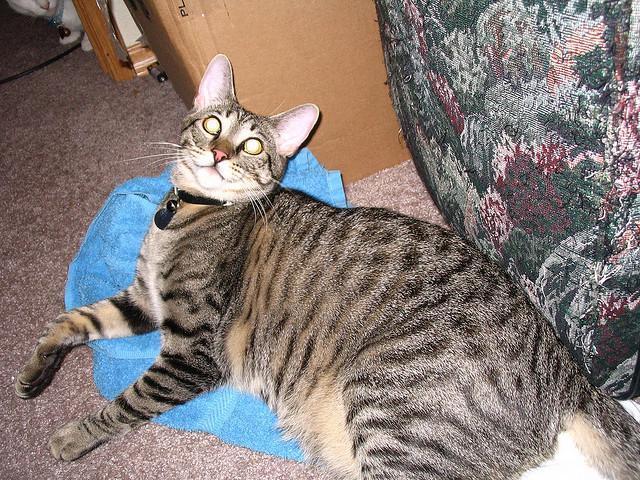How many red hearts in the photo?
Give a very brief answer. 0. How many people wearing red shirt?
Give a very brief answer. 0. 